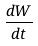Convert formula to latex. <formula><loc_0><loc_0><loc_500><loc_500>\frac { d W } { d t }</formula> 